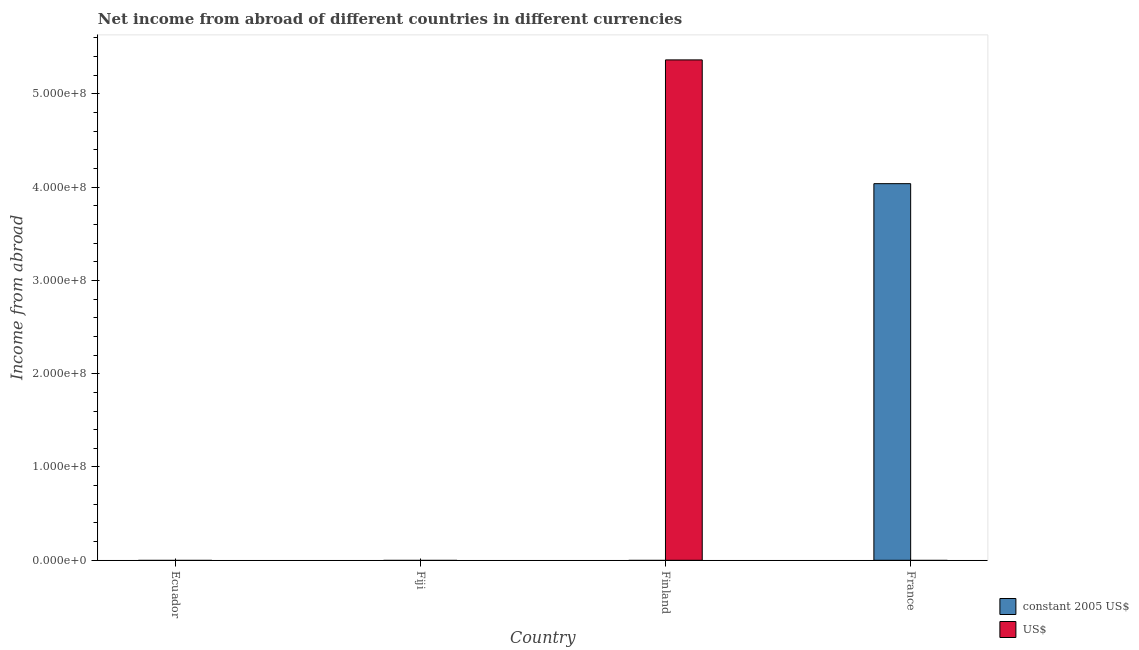How many different coloured bars are there?
Keep it short and to the point. 2. Are the number of bars per tick equal to the number of legend labels?
Keep it short and to the point. No. How many bars are there on the 2nd tick from the left?
Make the answer very short. 0. How many bars are there on the 1st tick from the right?
Your answer should be very brief. 1. What is the label of the 1st group of bars from the left?
Provide a succinct answer. Ecuador. What is the income from abroad in us$ in France?
Offer a terse response. 0. Across all countries, what is the maximum income from abroad in constant 2005 us$?
Give a very brief answer. 4.04e+08. Across all countries, what is the minimum income from abroad in us$?
Give a very brief answer. 0. In which country was the income from abroad in us$ maximum?
Give a very brief answer. Finland. What is the total income from abroad in constant 2005 us$ in the graph?
Ensure brevity in your answer.  4.04e+08. What is the difference between the income from abroad in constant 2005 us$ in Ecuador and the income from abroad in us$ in Finland?
Offer a terse response. -5.36e+08. What is the average income from abroad in constant 2005 us$ per country?
Ensure brevity in your answer.  1.01e+08. What is the difference between the highest and the lowest income from abroad in constant 2005 us$?
Offer a terse response. 4.04e+08. In how many countries, is the income from abroad in us$ greater than the average income from abroad in us$ taken over all countries?
Offer a terse response. 1. What is the difference between two consecutive major ticks on the Y-axis?
Provide a succinct answer. 1.00e+08. Are the values on the major ticks of Y-axis written in scientific E-notation?
Ensure brevity in your answer.  Yes. Does the graph contain grids?
Keep it short and to the point. No. How many legend labels are there?
Offer a very short reply. 2. What is the title of the graph?
Your answer should be compact. Net income from abroad of different countries in different currencies. Does "Depositors" appear as one of the legend labels in the graph?
Keep it short and to the point. No. What is the label or title of the Y-axis?
Offer a very short reply. Income from abroad. What is the Income from abroad of constant 2005 US$ in Fiji?
Make the answer very short. 0. What is the Income from abroad of constant 2005 US$ in Finland?
Your answer should be very brief. 0. What is the Income from abroad in US$ in Finland?
Your answer should be compact. 5.36e+08. What is the Income from abroad in constant 2005 US$ in France?
Provide a short and direct response. 4.04e+08. Across all countries, what is the maximum Income from abroad of constant 2005 US$?
Provide a succinct answer. 4.04e+08. Across all countries, what is the maximum Income from abroad in US$?
Ensure brevity in your answer.  5.36e+08. Across all countries, what is the minimum Income from abroad in US$?
Your answer should be very brief. 0. What is the total Income from abroad of constant 2005 US$ in the graph?
Your answer should be very brief. 4.04e+08. What is the total Income from abroad of US$ in the graph?
Offer a very short reply. 5.36e+08. What is the average Income from abroad of constant 2005 US$ per country?
Give a very brief answer. 1.01e+08. What is the average Income from abroad in US$ per country?
Your answer should be very brief. 1.34e+08. What is the difference between the highest and the lowest Income from abroad in constant 2005 US$?
Offer a very short reply. 4.04e+08. What is the difference between the highest and the lowest Income from abroad of US$?
Your answer should be compact. 5.36e+08. 